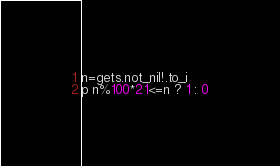<code> <loc_0><loc_0><loc_500><loc_500><_Crystal_>n=gets.not_nil!.to_i
p n%100*21<=n ? 1 : 0</code> 